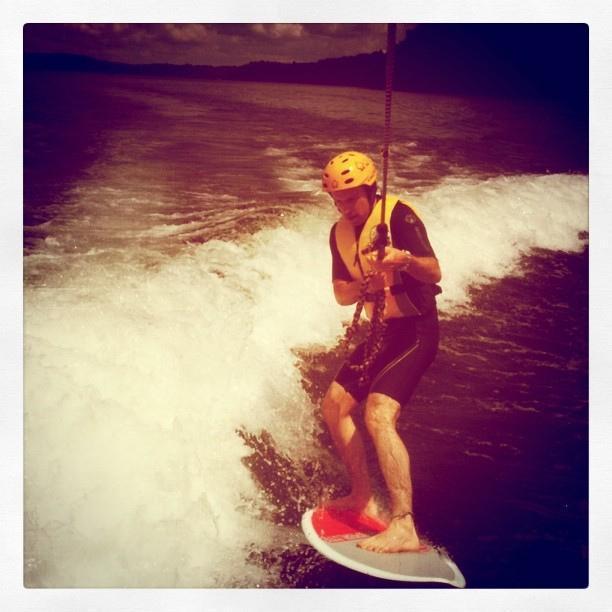How many wheels does the truck have?
Give a very brief answer. 0. 